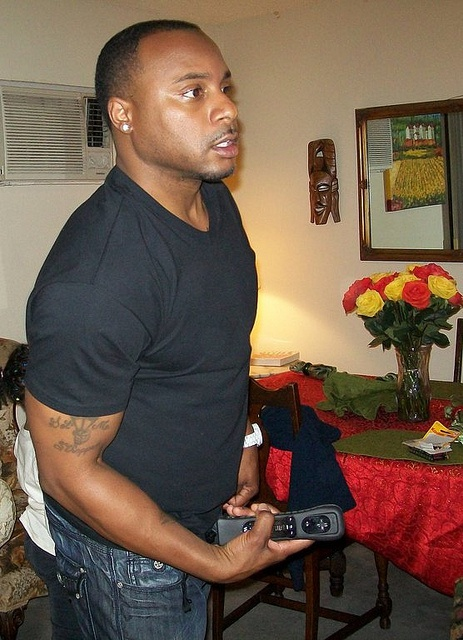Describe the objects in this image and their specific colors. I can see people in gray, black, brown, and darkblue tones, dining table in gray, black, maroon, darkgreen, and brown tones, chair in gray and black tones, potted plant in gray, black, brown, orange, and darkgreen tones, and couch in gray, black, and maroon tones in this image. 